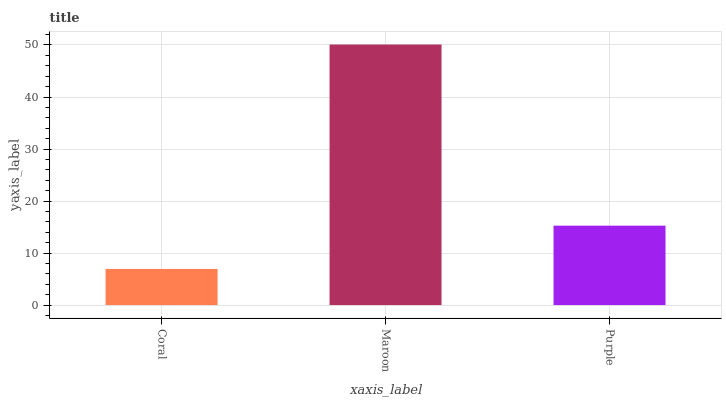Is Purple the minimum?
Answer yes or no. No. Is Purple the maximum?
Answer yes or no. No. Is Maroon greater than Purple?
Answer yes or no. Yes. Is Purple less than Maroon?
Answer yes or no. Yes. Is Purple greater than Maroon?
Answer yes or no. No. Is Maroon less than Purple?
Answer yes or no. No. Is Purple the high median?
Answer yes or no. Yes. Is Purple the low median?
Answer yes or no. Yes. Is Maroon the high median?
Answer yes or no. No. Is Maroon the low median?
Answer yes or no. No. 